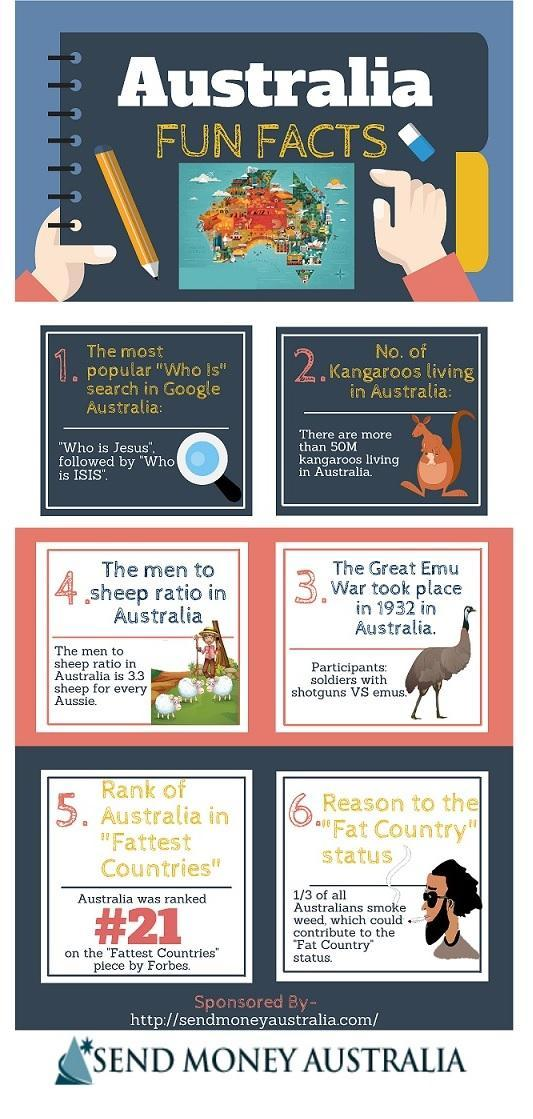Which is the most popular search "Who is Jesus" or "Who is ISIS"?
Answer the question with a short phrase. Who is Jesus How many fun facts are based on animals ? 3 